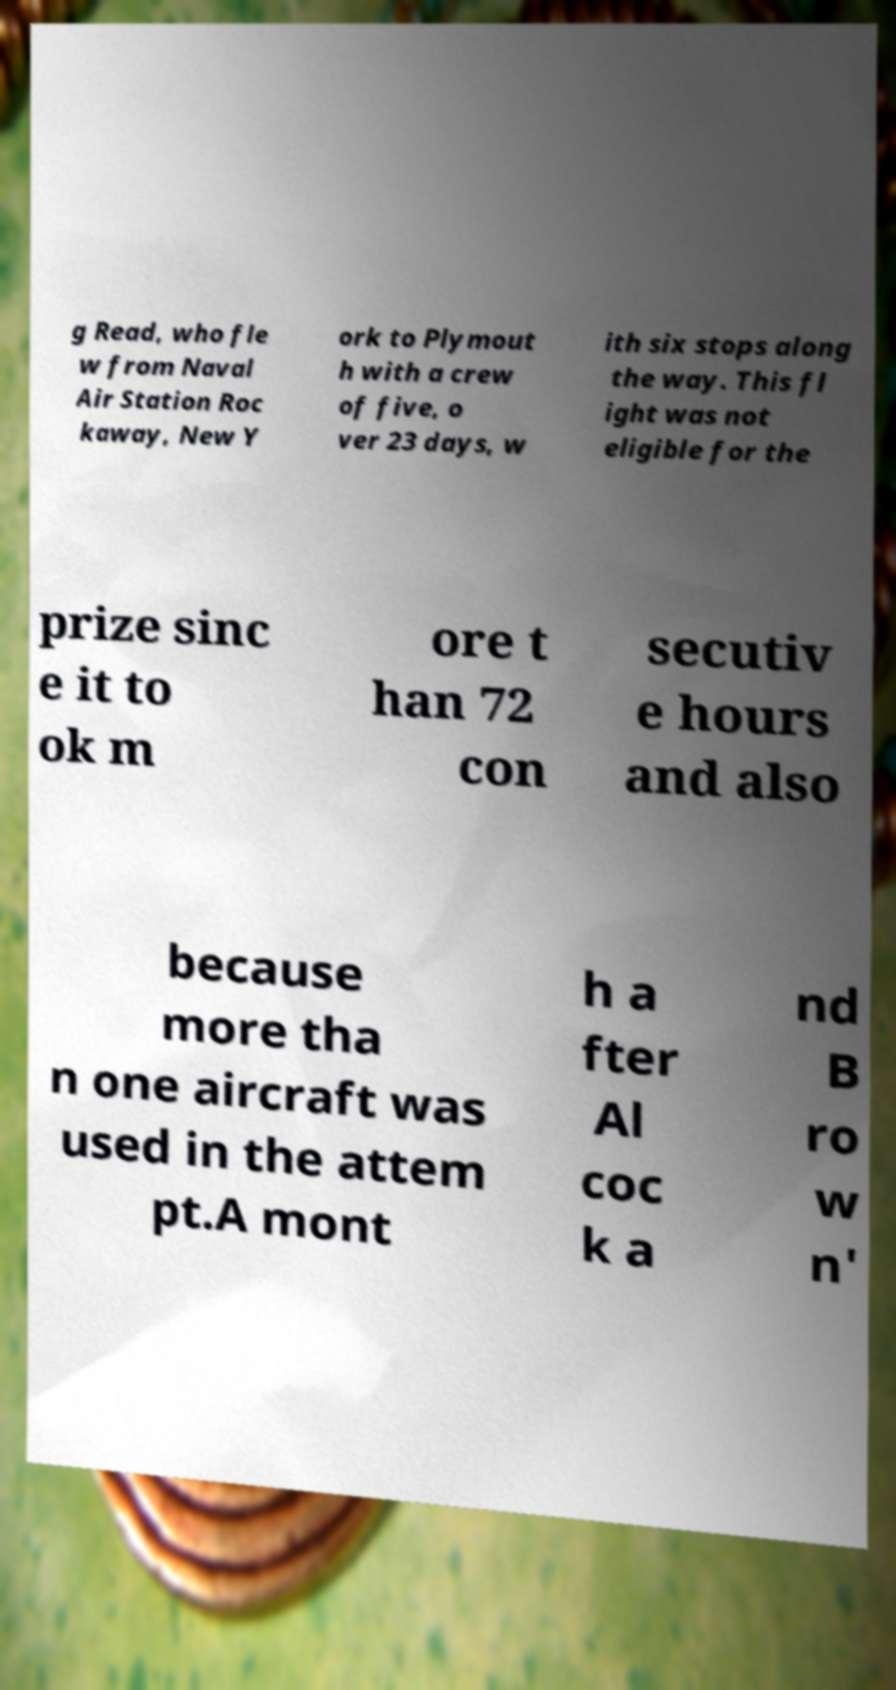Please identify and transcribe the text found in this image. g Read, who fle w from Naval Air Station Roc kaway, New Y ork to Plymout h with a crew of five, o ver 23 days, w ith six stops along the way. This fl ight was not eligible for the prize sinc e it to ok m ore t han 72 con secutiv e hours and also because more tha n one aircraft was used in the attem pt.A mont h a fter Al coc k a nd B ro w n' 